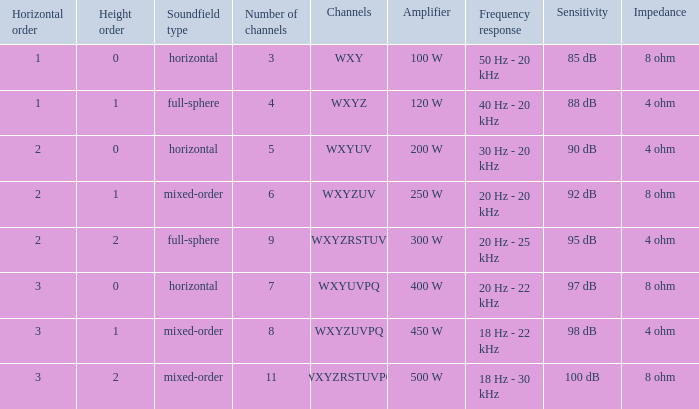If the height order is 1 and the soundfield type is mixed-order, what are all the channels? WXYZUV, WXYZUVPQ. 